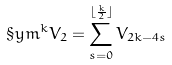Convert formula to latex. <formula><loc_0><loc_0><loc_500><loc_500>\S y m ^ { k } V _ { 2 } = \sum _ { s = 0 } ^ { \lfloor \frac { k } { 2 } \rfloor } V _ { 2 k - 4 s }</formula> 